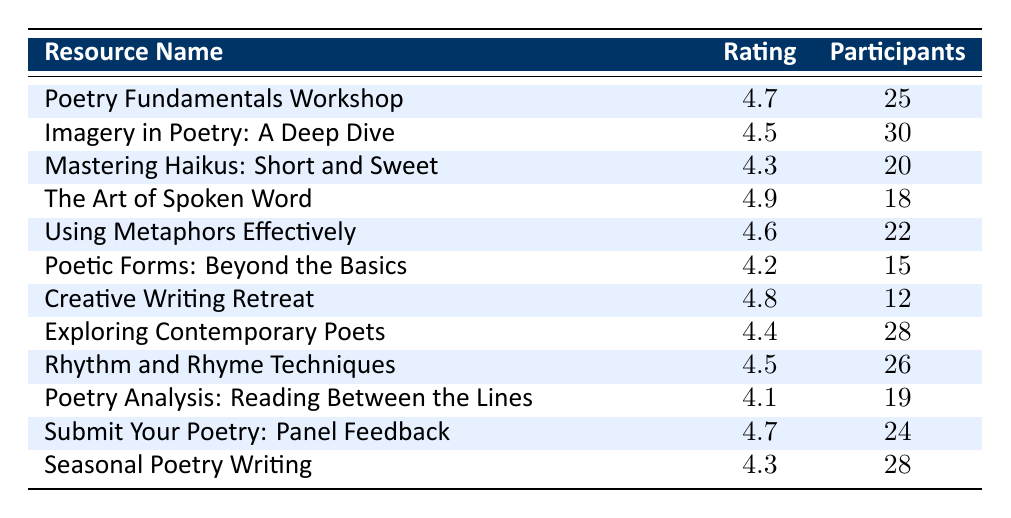What was the highest-rated workshop? The table shows that "The Art of Spoken Word" has the highest rating of 4.9.
Answer: 4.9 How many participants attended the "Mastering Haikus: Short and Sweet" workshop? The table lists 20 participants for the "Mastering Haikus: Short and Sweet" workshop.
Answer: 20 What is the average rating of the workshops held in 2023? The ratings from all workshops are (4.7 + 4.5 + 4.3 + 4.9 + 4.6 + 4.2 + 4.8 + 4.4 + 4.5 + 4.1 + 4.7 + 4.3) = 52.9, and there are 12 workshops, so the average is 52.9 / 12 = 4.41.
Answer: 4.41 Is there any workshop with a rating lower than 4.2? Yes, the "Poetic Forms: Beyond the Basics" workshop has a rating of 4.2, and "Poetry Analysis: Reading Between the Lines" has a rating of 4.1, which is lower than 4.2.
Answer: Yes Which workshop had the least number of participants? The "Creative Writing Retreat" had the least number of participants with a count of 12.
Answer: 12 What is the difference in ratings between the "Poetry Fundamentals Workshop" and "Rhythm and Rhyme Techniques"? The difference in ratings is calculated as 4.7 (Poetry Fundamentals) - 4.5 (Rhythm and Rhyme Techniques) = 0.2.
Answer: 0.2 How many workshops received a rating of 4.5 or higher? The workshops with ratings of 4.5 or higher are "Poetry Fundamentals Workshop", "Imagery in Poetry: A Deep Dive", "The Art of Spoken Word", "Using Metaphors Effectively", "Creative Writing Retreat", "Rhythm and Rhyme Techniques", and "Submit Your Poetry: Panel Feedback". This totals 7 workshops.
Answer: 7 Which workshop received the highest participant count, and what is that count? The workshop with the highest participant count is "Imagery in Poetry: A Deep Dive" with 30 participants.
Answer: 30 What percentage of workshops had a participant count of 25 or more? There are 12 total workshops, and those with 25 or more participants are "Poetry Fundamentals Workshop", "Imagery in Poetry: A Deep Dive", "Using Metaphors Effectively", "Rhythm and Rhyme Techniques", and "Submit Your Poetry: Panel Feedback", which totals 5 workshops. The percentage is (5/12)*100 = 41.67%.
Answer: 41.67% 